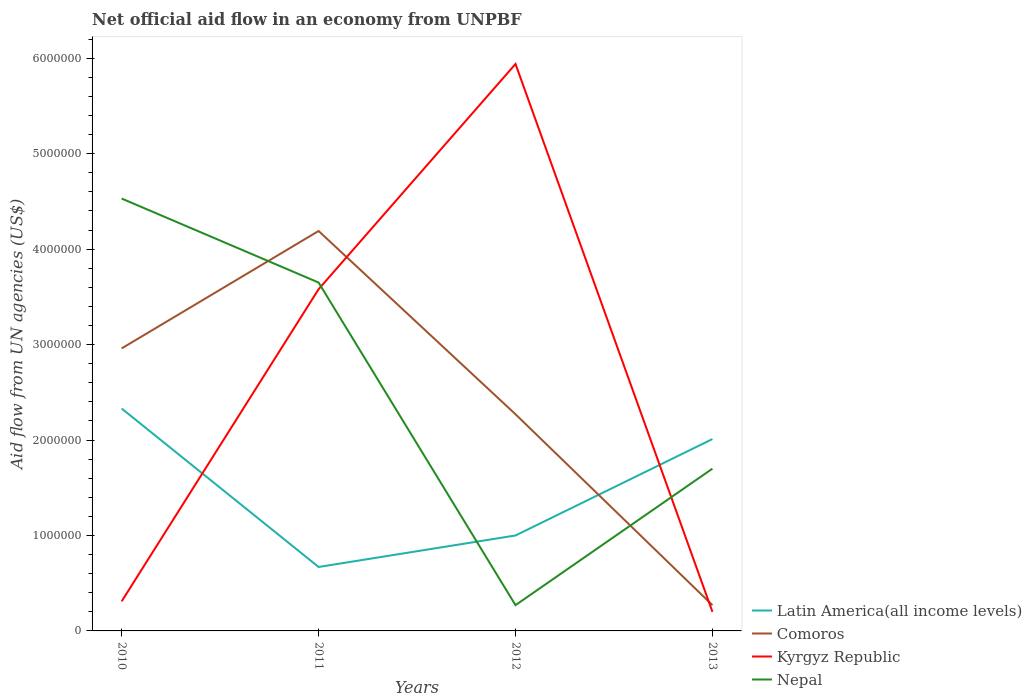Does the line corresponding to Nepal intersect with the line corresponding to Kyrgyz Republic?
Your answer should be compact. Yes. What is the total net official aid flow in Kyrgyz Republic in the graph?
Offer a terse response. 3.38e+06. What is the difference between the highest and the second highest net official aid flow in Kyrgyz Republic?
Your answer should be very brief. 5.74e+06. How many years are there in the graph?
Keep it short and to the point. 4. Are the values on the major ticks of Y-axis written in scientific E-notation?
Offer a terse response. No. Does the graph contain any zero values?
Offer a terse response. No. How many legend labels are there?
Offer a very short reply. 4. How are the legend labels stacked?
Make the answer very short. Vertical. What is the title of the graph?
Your answer should be compact. Net official aid flow in an economy from UNPBF. What is the label or title of the X-axis?
Offer a very short reply. Years. What is the label or title of the Y-axis?
Keep it short and to the point. Aid flow from UN agencies (US$). What is the Aid flow from UN agencies (US$) of Latin America(all income levels) in 2010?
Provide a short and direct response. 2.33e+06. What is the Aid flow from UN agencies (US$) of Comoros in 2010?
Offer a very short reply. 2.96e+06. What is the Aid flow from UN agencies (US$) in Kyrgyz Republic in 2010?
Make the answer very short. 3.10e+05. What is the Aid flow from UN agencies (US$) of Nepal in 2010?
Offer a very short reply. 4.53e+06. What is the Aid flow from UN agencies (US$) in Latin America(all income levels) in 2011?
Offer a very short reply. 6.70e+05. What is the Aid flow from UN agencies (US$) of Comoros in 2011?
Offer a terse response. 4.19e+06. What is the Aid flow from UN agencies (US$) of Kyrgyz Republic in 2011?
Ensure brevity in your answer.  3.58e+06. What is the Aid flow from UN agencies (US$) of Nepal in 2011?
Your answer should be very brief. 3.65e+06. What is the Aid flow from UN agencies (US$) in Latin America(all income levels) in 2012?
Your answer should be very brief. 1.00e+06. What is the Aid flow from UN agencies (US$) of Comoros in 2012?
Give a very brief answer. 2.27e+06. What is the Aid flow from UN agencies (US$) in Kyrgyz Republic in 2012?
Your answer should be compact. 5.94e+06. What is the Aid flow from UN agencies (US$) in Latin America(all income levels) in 2013?
Your answer should be compact. 2.01e+06. What is the Aid flow from UN agencies (US$) in Comoros in 2013?
Keep it short and to the point. 2.70e+05. What is the Aid flow from UN agencies (US$) of Kyrgyz Republic in 2013?
Your answer should be compact. 2.00e+05. What is the Aid flow from UN agencies (US$) in Nepal in 2013?
Give a very brief answer. 1.70e+06. Across all years, what is the maximum Aid flow from UN agencies (US$) of Latin America(all income levels)?
Give a very brief answer. 2.33e+06. Across all years, what is the maximum Aid flow from UN agencies (US$) in Comoros?
Offer a terse response. 4.19e+06. Across all years, what is the maximum Aid flow from UN agencies (US$) of Kyrgyz Republic?
Your answer should be very brief. 5.94e+06. Across all years, what is the maximum Aid flow from UN agencies (US$) in Nepal?
Your answer should be compact. 4.53e+06. Across all years, what is the minimum Aid flow from UN agencies (US$) of Latin America(all income levels)?
Ensure brevity in your answer.  6.70e+05. Across all years, what is the minimum Aid flow from UN agencies (US$) of Comoros?
Make the answer very short. 2.70e+05. What is the total Aid flow from UN agencies (US$) of Latin America(all income levels) in the graph?
Make the answer very short. 6.01e+06. What is the total Aid flow from UN agencies (US$) in Comoros in the graph?
Give a very brief answer. 9.69e+06. What is the total Aid flow from UN agencies (US$) of Kyrgyz Republic in the graph?
Provide a succinct answer. 1.00e+07. What is the total Aid flow from UN agencies (US$) of Nepal in the graph?
Make the answer very short. 1.02e+07. What is the difference between the Aid flow from UN agencies (US$) in Latin America(all income levels) in 2010 and that in 2011?
Your response must be concise. 1.66e+06. What is the difference between the Aid flow from UN agencies (US$) in Comoros in 2010 and that in 2011?
Ensure brevity in your answer.  -1.23e+06. What is the difference between the Aid flow from UN agencies (US$) in Kyrgyz Republic in 2010 and that in 2011?
Make the answer very short. -3.27e+06. What is the difference between the Aid flow from UN agencies (US$) in Nepal in 2010 and that in 2011?
Offer a terse response. 8.80e+05. What is the difference between the Aid flow from UN agencies (US$) of Latin America(all income levels) in 2010 and that in 2012?
Make the answer very short. 1.33e+06. What is the difference between the Aid flow from UN agencies (US$) of Comoros in 2010 and that in 2012?
Keep it short and to the point. 6.90e+05. What is the difference between the Aid flow from UN agencies (US$) in Kyrgyz Republic in 2010 and that in 2012?
Ensure brevity in your answer.  -5.63e+06. What is the difference between the Aid flow from UN agencies (US$) in Nepal in 2010 and that in 2012?
Make the answer very short. 4.26e+06. What is the difference between the Aid flow from UN agencies (US$) in Comoros in 2010 and that in 2013?
Ensure brevity in your answer.  2.69e+06. What is the difference between the Aid flow from UN agencies (US$) of Nepal in 2010 and that in 2013?
Offer a terse response. 2.83e+06. What is the difference between the Aid flow from UN agencies (US$) of Latin America(all income levels) in 2011 and that in 2012?
Provide a short and direct response. -3.30e+05. What is the difference between the Aid flow from UN agencies (US$) in Comoros in 2011 and that in 2012?
Provide a succinct answer. 1.92e+06. What is the difference between the Aid flow from UN agencies (US$) in Kyrgyz Republic in 2011 and that in 2012?
Your answer should be very brief. -2.36e+06. What is the difference between the Aid flow from UN agencies (US$) of Nepal in 2011 and that in 2012?
Give a very brief answer. 3.38e+06. What is the difference between the Aid flow from UN agencies (US$) of Latin America(all income levels) in 2011 and that in 2013?
Provide a short and direct response. -1.34e+06. What is the difference between the Aid flow from UN agencies (US$) in Comoros in 2011 and that in 2013?
Provide a short and direct response. 3.92e+06. What is the difference between the Aid flow from UN agencies (US$) of Kyrgyz Republic in 2011 and that in 2013?
Give a very brief answer. 3.38e+06. What is the difference between the Aid flow from UN agencies (US$) in Nepal in 2011 and that in 2013?
Provide a short and direct response. 1.95e+06. What is the difference between the Aid flow from UN agencies (US$) of Latin America(all income levels) in 2012 and that in 2013?
Make the answer very short. -1.01e+06. What is the difference between the Aid flow from UN agencies (US$) in Comoros in 2012 and that in 2013?
Make the answer very short. 2.00e+06. What is the difference between the Aid flow from UN agencies (US$) of Kyrgyz Republic in 2012 and that in 2013?
Keep it short and to the point. 5.74e+06. What is the difference between the Aid flow from UN agencies (US$) of Nepal in 2012 and that in 2013?
Make the answer very short. -1.43e+06. What is the difference between the Aid flow from UN agencies (US$) in Latin America(all income levels) in 2010 and the Aid flow from UN agencies (US$) in Comoros in 2011?
Provide a short and direct response. -1.86e+06. What is the difference between the Aid flow from UN agencies (US$) of Latin America(all income levels) in 2010 and the Aid flow from UN agencies (US$) of Kyrgyz Republic in 2011?
Make the answer very short. -1.25e+06. What is the difference between the Aid flow from UN agencies (US$) in Latin America(all income levels) in 2010 and the Aid flow from UN agencies (US$) in Nepal in 2011?
Give a very brief answer. -1.32e+06. What is the difference between the Aid flow from UN agencies (US$) of Comoros in 2010 and the Aid flow from UN agencies (US$) of Kyrgyz Republic in 2011?
Keep it short and to the point. -6.20e+05. What is the difference between the Aid flow from UN agencies (US$) of Comoros in 2010 and the Aid flow from UN agencies (US$) of Nepal in 2011?
Your response must be concise. -6.90e+05. What is the difference between the Aid flow from UN agencies (US$) of Kyrgyz Republic in 2010 and the Aid flow from UN agencies (US$) of Nepal in 2011?
Your response must be concise. -3.34e+06. What is the difference between the Aid flow from UN agencies (US$) of Latin America(all income levels) in 2010 and the Aid flow from UN agencies (US$) of Comoros in 2012?
Your answer should be very brief. 6.00e+04. What is the difference between the Aid flow from UN agencies (US$) in Latin America(all income levels) in 2010 and the Aid flow from UN agencies (US$) in Kyrgyz Republic in 2012?
Keep it short and to the point. -3.61e+06. What is the difference between the Aid flow from UN agencies (US$) in Latin America(all income levels) in 2010 and the Aid flow from UN agencies (US$) in Nepal in 2012?
Give a very brief answer. 2.06e+06. What is the difference between the Aid flow from UN agencies (US$) in Comoros in 2010 and the Aid flow from UN agencies (US$) in Kyrgyz Republic in 2012?
Offer a very short reply. -2.98e+06. What is the difference between the Aid flow from UN agencies (US$) in Comoros in 2010 and the Aid flow from UN agencies (US$) in Nepal in 2012?
Make the answer very short. 2.69e+06. What is the difference between the Aid flow from UN agencies (US$) in Kyrgyz Republic in 2010 and the Aid flow from UN agencies (US$) in Nepal in 2012?
Offer a terse response. 4.00e+04. What is the difference between the Aid flow from UN agencies (US$) of Latin America(all income levels) in 2010 and the Aid flow from UN agencies (US$) of Comoros in 2013?
Your answer should be compact. 2.06e+06. What is the difference between the Aid flow from UN agencies (US$) in Latin America(all income levels) in 2010 and the Aid flow from UN agencies (US$) in Kyrgyz Republic in 2013?
Your response must be concise. 2.13e+06. What is the difference between the Aid flow from UN agencies (US$) in Latin America(all income levels) in 2010 and the Aid flow from UN agencies (US$) in Nepal in 2013?
Offer a very short reply. 6.30e+05. What is the difference between the Aid flow from UN agencies (US$) of Comoros in 2010 and the Aid flow from UN agencies (US$) of Kyrgyz Republic in 2013?
Ensure brevity in your answer.  2.76e+06. What is the difference between the Aid flow from UN agencies (US$) in Comoros in 2010 and the Aid flow from UN agencies (US$) in Nepal in 2013?
Your answer should be compact. 1.26e+06. What is the difference between the Aid flow from UN agencies (US$) of Kyrgyz Republic in 2010 and the Aid flow from UN agencies (US$) of Nepal in 2013?
Provide a short and direct response. -1.39e+06. What is the difference between the Aid flow from UN agencies (US$) in Latin America(all income levels) in 2011 and the Aid flow from UN agencies (US$) in Comoros in 2012?
Offer a terse response. -1.60e+06. What is the difference between the Aid flow from UN agencies (US$) of Latin America(all income levels) in 2011 and the Aid flow from UN agencies (US$) of Kyrgyz Republic in 2012?
Give a very brief answer. -5.27e+06. What is the difference between the Aid flow from UN agencies (US$) of Latin America(all income levels) in 2011 and the Aid flow from UN agencies (US$) of Nepal in 2012?
Ensure brevity in your answer.  4.00e+05. What is the difference between the Aid flow from UN agencies (US$) of Comoros in 2011 and the Aid flow from UN agencies (US$) of Kyrgyz Republic in 2012?
Offer a terse response. -1.75e+06. What is the difference between the Aid flow from UN agencies (US$) in Comoros in 2011 and the Aid flow from UN agencies (US$) in Nepal in 2012?
Provide a succinct answer. 3.92e+06. What is the difference between the Aid flow from UN agencies (US$) in Kyrgyz Republic in 2011 and the Aid flow from UN agencies (US$) in Nepal in 2012?
Provide a succinct answer. 3.31e+06. What is the difference between the Aid flow from UN agencies (US$) in Latin America(all income levels) in 2011 and the Aid flow from UN agencies (US$) in Kyrgyz Republic in 2013?
Provide a succinct answer. 4.70e+05. What is the difference between the Aid flow from UN agencies (US$) in Latin America(all income levels) in 2011 and the Aid flow from UN agencies (US$) in Nepal in 2013?
Make the answer very short. -1.03e+06. What is the difference between the Aid flow from UN agencies (US$) of Comoros in 2011 and the Aid flow from UN agencies (US$) of Kyrgyz Republic in 2013?
Keep it short and to the point. 3.99e+06. What is the difference between the Aid flow from UN agencies (US$) in Comoros in 2011 and the Aid flow from UN agencies (US$) in Nepal in 2013?
Provide a succinct answer. 2.49e+06. What is the difference between the Aid flow from UN agencies (US$) of Kyrgyz Republic in 2011 and the Aid flow from UN agencies (US$) of Nepal in 2013?
Make the answer very short. 1.88e+06. What is the difference between the Aid flow from UN agencies (US$) in Latin America(all income levels) in 2012 and the Aid flow from UN agencies (US$) in Comoros in 2013?
Your response must be concise. 7.30e+05. What is the difference between the Aid flow from UN agencies (US$) in Latin America(all income levels) in 2012 and the Aid flow from UN agencies (US$) in Kyrgyz Republic in 2013?
Your answer should be compact. 8.00e+05. What is the difference between the Aid flow from UN agencies (US$) of Latin America(all income levels) in 2012 and the Aid flow from UN agencies (US$) of Nepal in 2013?
Offer a terse response. -7.00e+05. What is the difference between the Aid flow from UN agencies (US$) in Comoros in 2012 and the Aid flow from UN agencies (US$) in Kyrgyz Republic in 2013?
Offer a very short reply. 2.07e+06. What is the difference between the Aid flow from UN agencies (US$) in Comoros in 2012 and the Aid flow from UN agencies (US$) in Nepal in 2013?
Offer a terse response. 5.70e+05. What is the difference between the Aid flow from UN agencies (US$) of Kyrgyz Republic in 2012 and the Aid flow from UN agencies (US$) of Nepal in 2013?
Offer a terse response. 4.24e+06. What is the average Aid flow from UN agencies (US$) of Latin America(all income levels) per year?
Make the answer very short. 1.50e+06. What is the average Aid flow from UN agencies (US$) of Comoros per year?
Your answer should be compact. 2.42e+06. What is the average Aid flow from UN agencies (US$) of Kyrgyz Republic per year?
Make the answer very short. 2.51e+06. What is the average Aid flow from UN agencies (US$) in Nepal per year?
Ensure brevity in your answer.  2.54e+06. In the year 2010, what is the difference between the Aid flow from UN agencies (US$) of Latin America(all income levels) and Aid flow from UN agencies (US$) of Comoros?
Make the answer very short. -6.30e+05. In the year 2010, what is the difference between the Aid flow from UN agencies (US$) of Latin America(all income levels) and Aid flow from UN agencies (US$) of Kyrgyz Republic?
Make the answer very short. 2.02e+06. In the year 2010, what is the difference between the Aid flow from UN agencies (US$) in Latin America(all income levels) and Aid flow from UN agencies (US$) in Nepal?
Ensure brevity in your answer.  -2.20e+06. In the year 2010, what is the difference between the Aid flow from UN agencies (US$) of Comoros and Aid flow from UN agencies (US$) of Kyrgyz Republic?
Offer a very short reply. 2.65e+06. In the year 2010, what is the difference between the Aid flow from UN agencies (US$) of Comoros and Aid flow from UN agencies (US$) of Nepal?
Your answer should be very brief. -1.57e+06. In the year 2010, what is the difference between the Aid flow from UN agencies (US$) of Kyrgyz Republic and Aid flow from UN agencies (US$) of Nepal?
Make the answer very short. -4.22e+06. In the year 2011, what is the difference between the Aid flow from UN agencies (US$) of Latin America(all income levels) and Aid flow from UN agencies (US$) of Comoros?
Make the answer very short. -3.52e+06. In the year 2011, what is the difference between the Aid flow from UN agencies (US$) in Latin America(all income levels) and Aid flow from UN agencies (US$) in Kyrgyz Republic?
Your answer should be very brief. -2.91e+06. In the year 2011, what is the difference between the Aid flow from UN agencies (US$) of Latin America(all income levels) and Aid flow from UN agencies (US$) of Nepal?
Offer a very short reply. -2.98e+06. In the year 2011, what is the difference between the Aid flow from UN agencies (US$) of Comoros and Aid flow from UN agencies (US$) of Kyrgyz Republic?
Ensure brevity in your answer.  6.10e+05. In the year 2011, what is the difference between the Aid flow from UN agencies (US$) in Comoros and Aid flow from UN agencies (US$) in Nepal?
Ensure brevity in your answer.  5.40e+05. In the year 2011, what is the difference between the Aid flow from UN agencies (US$) of Kyrgyz Republic and Aid flow from UN agencies (US$) of Nepal?
Provide a short and direct response. -7.00e+04. In the year 2012, what is the difference between the Aid flow from UN agencies (US$) in Latin America(all income levels) and Aid flow from UN agencies (US$) in Comoros?
Provide a short and direct response. -1.27e+06. In the year 2012, what is the difference between the Aid flow from UN agencies (US$) of Latin America(all income levels) and Aid flow from UN agencies (US$) of Kyrgyz Republic?
Ensure brevity in your answer.  -4.94e+06. In the year 2012, what is the difference between the Aid flow from UN agencies (US$) of Latin America(all income levels) and Aid flow from UN agencies (US$) of Nepal?
Your answer should be very brief. 7.30e+05. In the year 2012, what is the difference between the Aid flow from UN agencies (US$) of Comoros and Aid flow from UN agencies (US$) of Kyrgyz Republic?
Provide a short and direct response. -3.67e+06. In the year 2012, what is the difference between the Aid flow from UN agencies (US$) of Comoros and Aid flow from UN agencies (US$) of Nepal?
Provide a short and direct response. 2.00e+06. In the year 2012, what is the difference between the Aid flow from UN agencies (US$) in Kyrgyz Republic and Aid flow from UN agencies (US$) in Nepal?
Offer a very short reply. 5.67e+06. In the year 2013, what is the difference between the Aid flow from UN agencies (US$) of Latin America(all income levels) and Aid flow from UN agencies (US$) of Comoros?
Provide a succinct answer. 1.74e+06. In the year 2013, what is the difference between the Aid flow from UN agencies (US$) of Latin America(all income levels) and Aid flow from UN agencies (US$) of Kyrgyz Republic?
Ensure brevity in your answer.  1.81e+06. In the year 2013, what is the difference between the Aid flow from UN agencies (US$) of Latin America(all income levels) and Aid flow from UN agencies (US$) of Nepal?
Give a very brief answer. 3.10e+05. In the year 2013, what is the difference between the Aid flow from UN agencies (US$) in Comoros and Aid flow from UN agencies (US$) in Kyrgyz Republic?
Provide a short and direct response. 7.00e+04. In the year 2013, what is the difference between the Aid flow from UN agencies (US$) in Comoros and Aid flow from UN agencies (US$) in Nepal?
Keep it short and to the point. -1.43e+06. In the year 2013, what is the difference between the Aid flow from UN agencies (US$) in Kyrgyz Republic and Aid flow from UN agencies (US$) in Nepal?
Offer a terse response. -1.50e+06. What is the ratio of the Aid flow from UN agencies (US$) in Latin America(all income levels) in 2010 to that in 2011?
Offer a terse response. 3.48. What is the ratio of the Aid flow from UN agencies (US$) in Comoros in 2010 to that in 2011?
Your response must be concise. 0.71. What is the ratio of the Aid flow from UN agencies (US$) of Kyrgyz Republic in 2010 to that in 2011?
Your answer should be compact. 0.09. What is the ratio of the Aid flow from UN agencies (US$) in Nepal in 2010 to that in 2011?
Your answer should be compact. 1.24. What is the ratio of the Aid flow from UN agencies (US$) of Latin America(all income levels) in 2010 to that in 2012?
Offer a very short reply. 2.33. What is the ratio of the Aid flow from UN agencies (US$) in Comoros in 2010 to that in 2012?
Keep it short and to the point. 1.3. What is the ratio of the Aid flow from UN agencies (US$) of Kyrgyz Republic in 2010 to that in 2012?
Make the answer very short. 0.05. What is the ratio of the Aid flow from UN agencies (US$) of Nepal in 2010 to that in 2012?
Offer a terse response. 16.78. What is the ratio of the Aid flow from UN agencies (US$) in Latin America(all income levels) in 2010 to that in 2013?
Give a very brief answer. 1.16. What is the ratio of the Aid flow from UN agencies (US$) of Comoros in 2010 to that in 2013?
Keep it short and to the point. 10.96. What is the ratio of the Aid flow from UN agencies (US$) in Kyrgyz Republic in 2010 to that in 2013?
Give a very brief answer. 1.55. What is the ratio of the Aid flow from UN agencies (US$) of Nepal in 2010 to that in 2013?
Keep it short and to the point. 2.66. What is the ratio of the Aid flow from UN agencies (US$) in Latin America(all income levels) in 2011 to that in 2012?
Offer a very short reply. 0.67. What is the ratio of the Aid flow from UN agencies (US$) in Comoros in 2011 to that in 2012?
Make the answer very short. 1.85. What is the ratio of the Aid flow from UN agencies (US$) of Kyrgyz Republic in 2011 to that in 2012?
Make the answer very short. 0.6. What is the ratio of the Aid flow from UN agencies (US$) of Nepal in 2011 to that in 2012?
Give a very brief answer. 13.52. What is the ratio of the Aid flow from UN agencies (US$) in Comoros in 2011 to that in 2013?
Offer a terse response. 15.52. What is the ratio of the Aid flow from UN agencies (US$) of Kyrgyz Republic in 2011 to that in 2013?
Offer a very short reply. 17.9. What is the ratio of the Aid flow from UN agencies (US$) of Nepal in 2011 to that in 2013?
Offer a very short reply. 2.15. What is the ratio of the Aid flow from UN agencies (US$) in Latin America(all income levels) in 2012 to that in 2013?
Provide a succinct answer. 0.5. What is the ratio of the Aid flow from UN agencies (US$) of Comoros in 2012 to that in 2013?
Provide a short and direct response. 8.41. What is the ratio of the Aid flow from UN agencies (US$) in Kyrgyz Republic in 2012 to that in 2013?
Ensure brevity in your answer.  29.7. What is the ratio of the Aid flow from UN agencies (US$) of Nepal in 2012 to that in 2013?
Your response must be concise. 0.16. What is the difference between the highest and the second highest Aid flow from UN agencies (US$) in Comoros?
Keep it short and to the point. 1.23e+06. What is the difference between the highest and the second highest Aid flow from UN agencies (US$) in Kyrgyz Republic?
Your response must be concise. 2.36e+06. What is the difference between the highest and the second highest Aid flow from UN agencies (US$) in Nepal?
Your response must be concise. 8.80e+05. What is the difference between the highest and the lowest Aid flow from UN agencies (US$) in Latin America(all income levels)?
Your answer should be very brief. 1.66e+06. What is the difference between the highest and the lowest Aid flow from UN agencies (US$) in Comoros?
Your answer should be very brief. 3.92e+06. What is the difference between the highest and the lowest Aid flow from UN agencies (US$) in Kyrgyz Republic?
Provide a short and direct response. 5.74e+06. What is the difference between the highest and the lowest Aid flow from UN agencies (US$) of Nepal?
Ensure brevity in your answer.  4.26e+06. 